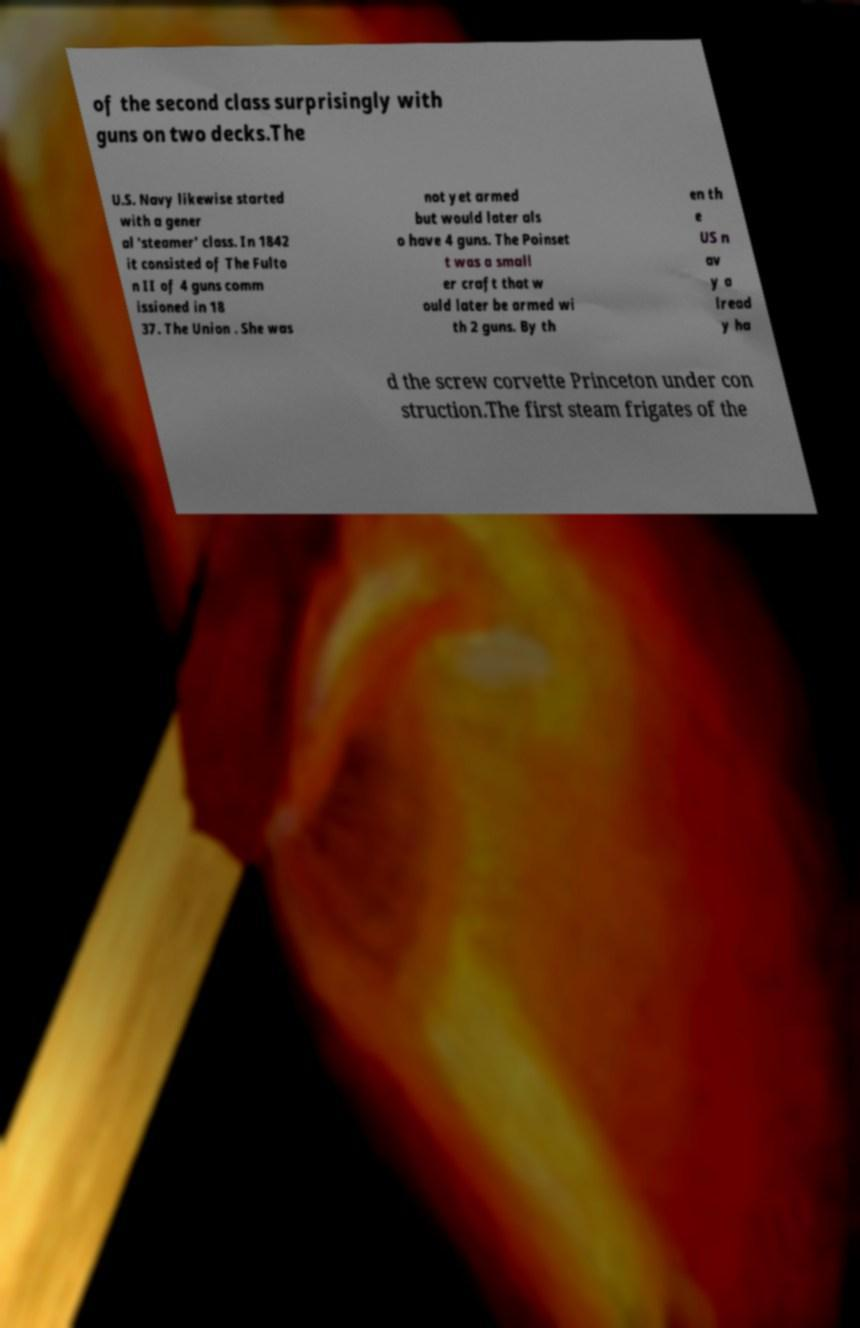I need the written content from this picture converted into text. Can you do that? of the second class surprisingly with guns on two decks.The U.S. Navy likewise started with a gener al 'steamer' class. In 1842 it consisted of The Fulto n II of 4 guns comm issioned in 18 37. The Union . She was not yet armed but would later als o have 4 guns. The Poinset t was a small er craft that w ould later be armed wi th 2 guns. By th en th e US n av y a lread y ha d the screw corvette Princeton under con struction.The first steam frigates of the 